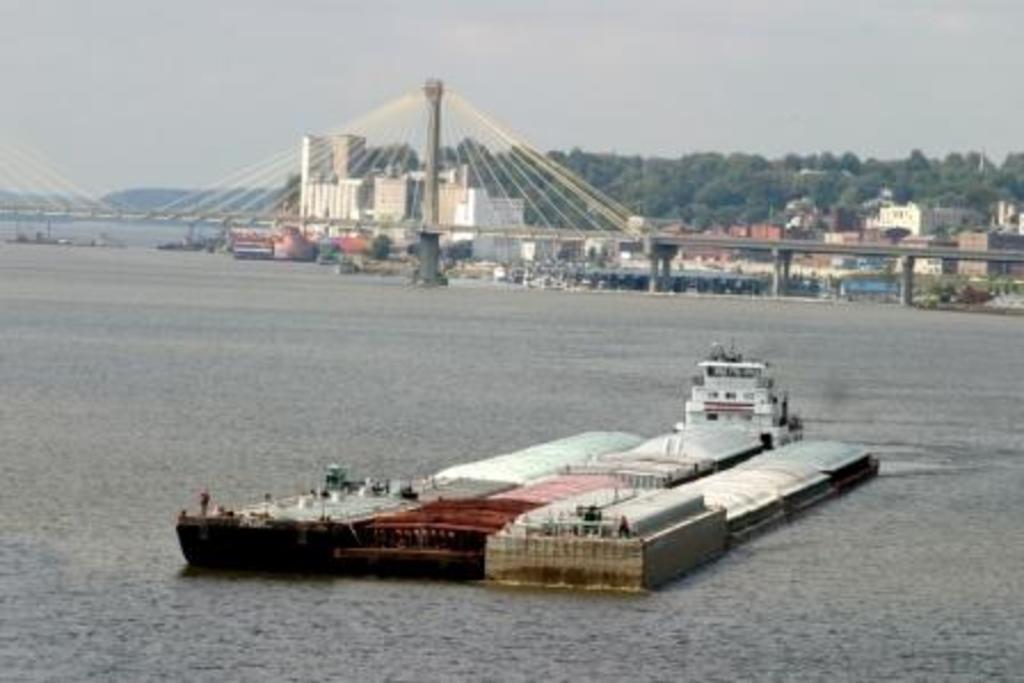How would you summarize this image in a sentence or two? In the image on the water there is a ship. Above the water there is a bridge with poles and ropes. Behind the bridge there are trees and buildings. At the top of the image there is sky. 